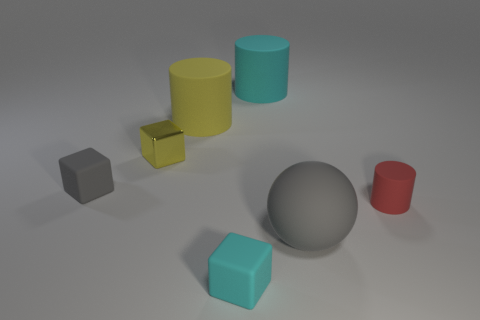Add 1 blue metal balls. How many objects exist? 8 Subtract all spheres. How many objects are left? 6 Add 5 small gray matte objects. How many small gray matte objects exist? 6 Subtract 0 blue cylinders. How many objects are left? 7 Subtract all big things. Subtract all cyan objects. How many objects are left? 2 Add 5 large cyan cylinders. How many large cyan cylinders are left? 6 